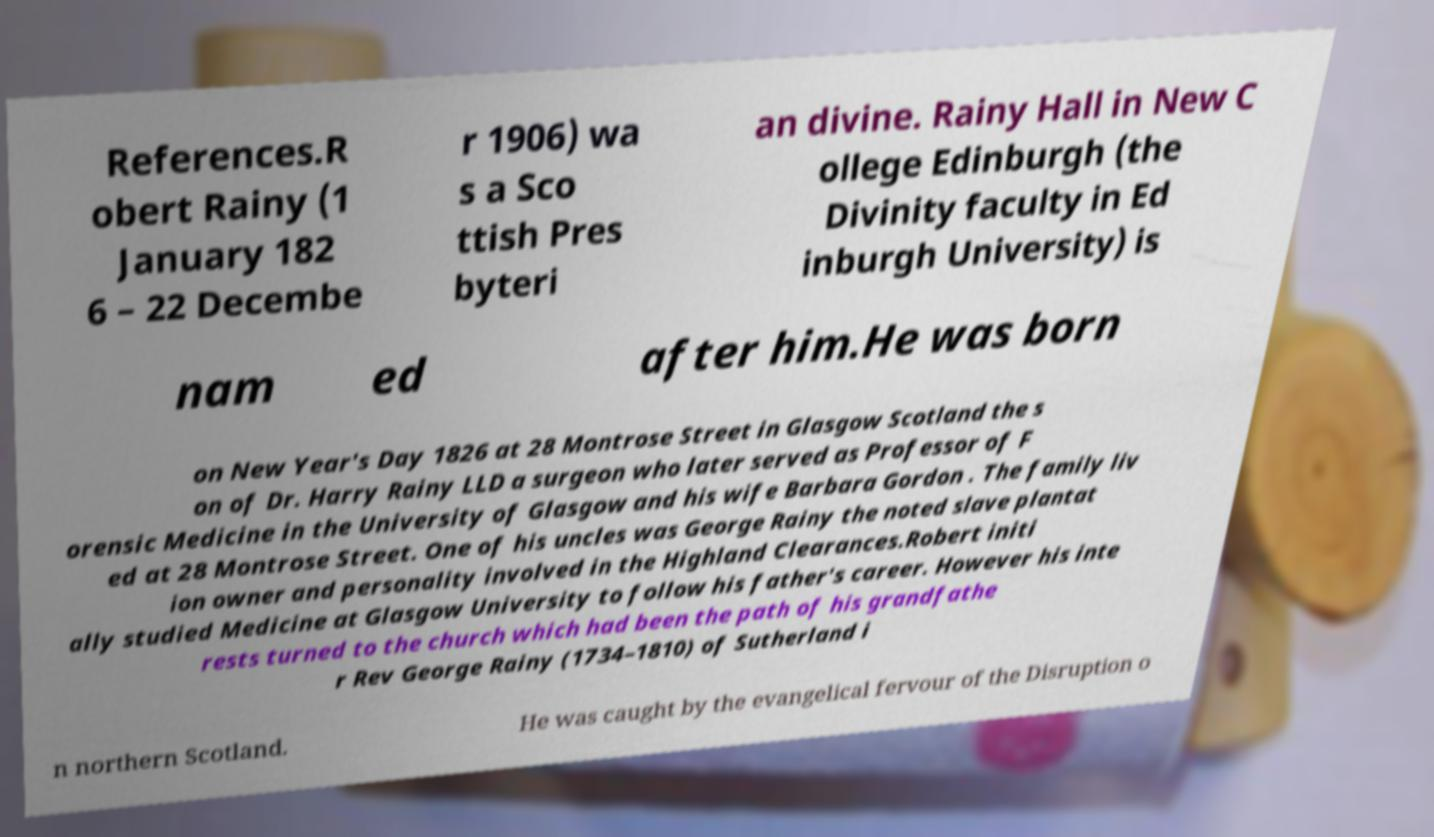I need the written content from this picture converted into text. Can you do that? References.R obert Rainy (1 January 182 6 – 22 Decembe r 1906) wa s a Sco ttish Pres byteri an divine. Rainy Hall in New C ollege Edinburgh (the Divinity faculty in Ed inburgh University) is nam ed after him.He was born on New Year's Day 1826 at 28 Montrose Street in Glasgow Scotland the s on of Dr. Harry Rainy LLD a surgeon who later served as Professor of F orensic Medicine in the University of Glasgow and his wife Barbara Gordon . The family liv ed at 28 Montrose Street. One of his uncles was George Rainy the noted slave plantat ion owner and personality involved in the Highland Clearances.Robert initi ally studied Medicine at Glasgow University to follow his father's career. However his inte rests turned to the church which had been the path of his grandfathe r Rev George Rainy (1734–1810) of Sutherland i n northern Scotland. He was caught by the evangelical fervour of the Disruption o 